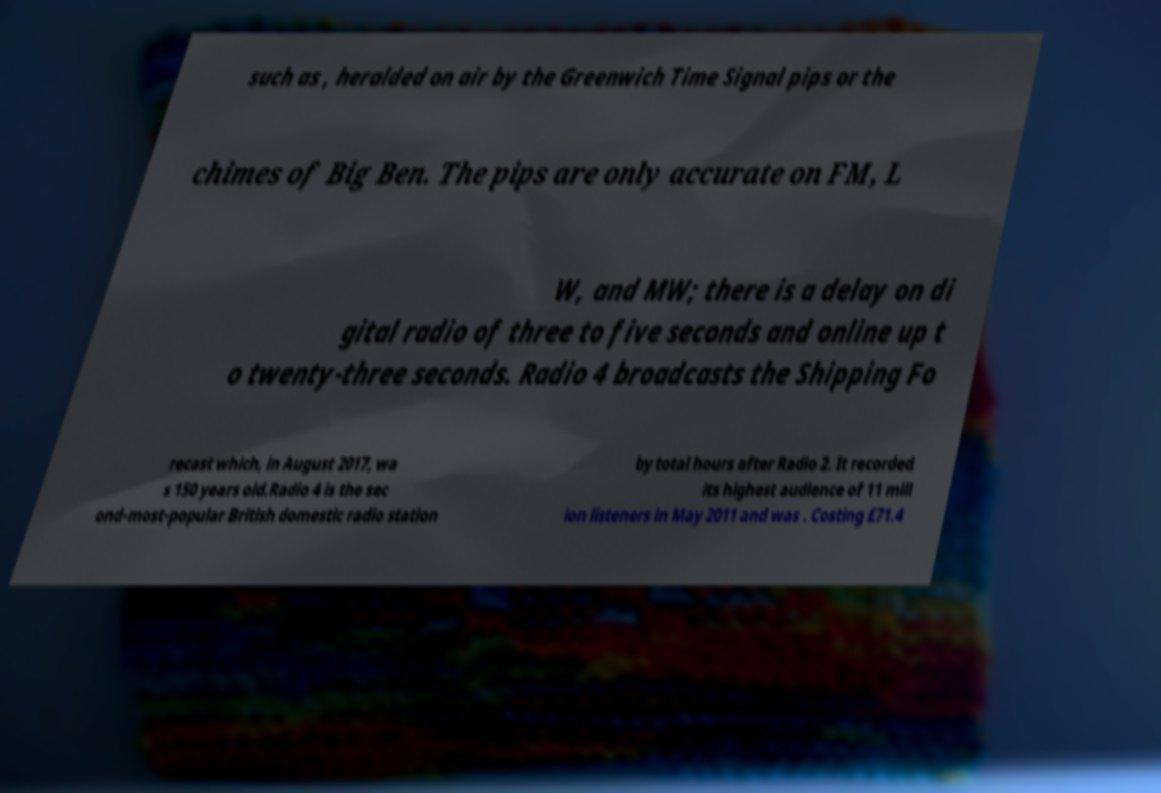What messages or text are displayed in this image? I need them in a readable, typed format. such as , heralded on air by the Greenwich Time Signal pips or the chimes of Big Ben. The pips are only accurate on FM, L W, and MW; there is a delay on di gital radio of three to five seconds and online up t o twenty-three seconds. Radio 4 broadcasts the Shipping Fo recast which, in August 2017, wa s 150 years old.Radio 4 is the sec ond-most-popular British domestic radio station by total hours after Radio 2. It recorded its highest audience of 11 mill ion listeners in May 2011 and was . Costing £71.4 